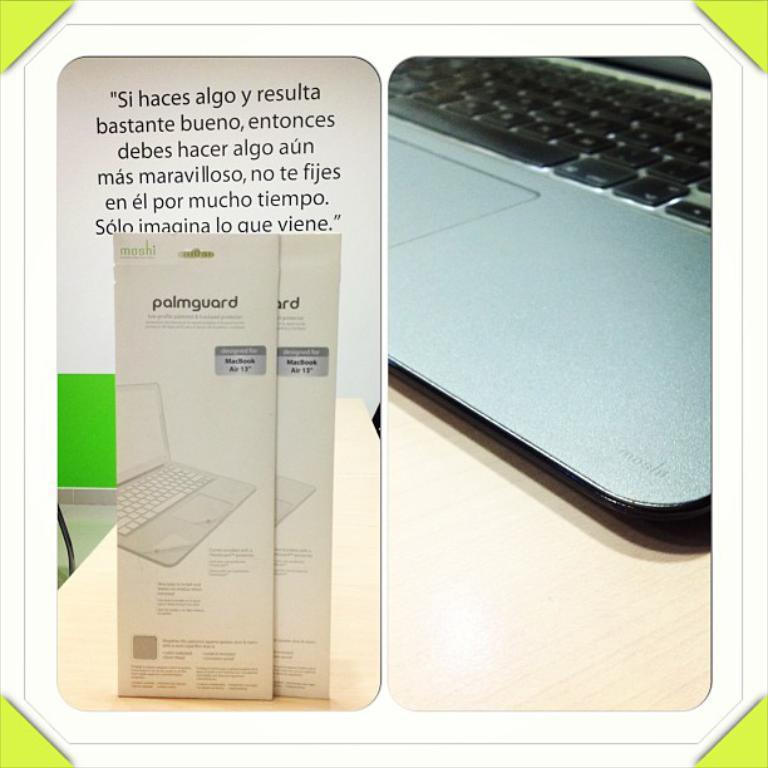<image>
Give a short and clear explanation of the subsequent image. A palm guard for a computer is shown next to a laptop. 